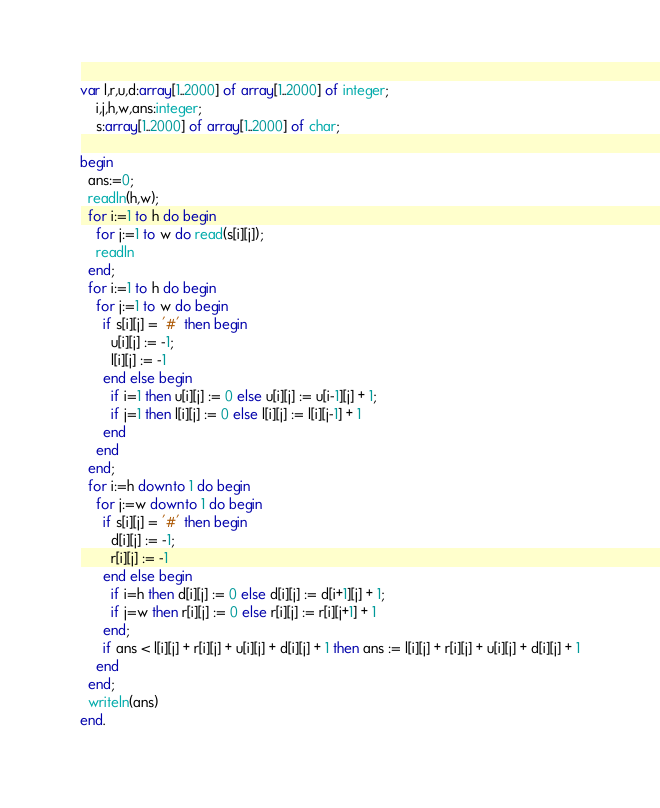Convert code to text. <code><loc_0><loc_0><loc_500><loc_500><_Pascal_>var l,r,u,d:array[1..2000] of array[1..2000] of integer;
    i,j,h,w,ans:integer;
    s:array[1..2000] of array[1..2000] of char;

begin
  ans:=0;
  readln(h,w);
  for i:=1 to h do begin
    for j:=1 to w do read(s[i][j]);
    readln
  end;
  for i:=1 to h do begin
    for j:=1 to w do begin
      if s[i][j] = '#' then begin
        u[i][j] := -1;
        l[i][j] := -1
      end else begin
        if i=1 then u[i][j] := 0 else u[i][j] := u[i-1][j] + 1;
        if j=1 then l[i][j] := 0 else l[i][j] := l[i][j-1] + 1
      end
    end
  end;
  for i:=h downto 1 do begin
    for j:=w downto 1 do begin
      if s[i][j] = '#' then begin
        d[i][j] := -1;
        r[i][j] := -1
      end else begin
        if i=h then d[i][j] := 0 else d[i][j] := d[i+1][j] + 1;
        if j=w then r[i][j] := 0 else r[i][j] := r[i][j+1] + 1
      end;
      if ans < l[i][j] + r[i][j] + u[i][j] + d[i][j] + 1 then ans := l[i][j] + r[i][j] + u[i][j] + d[i][j] + 1
    end
  end;
  writeln(ans)
end.</code> 